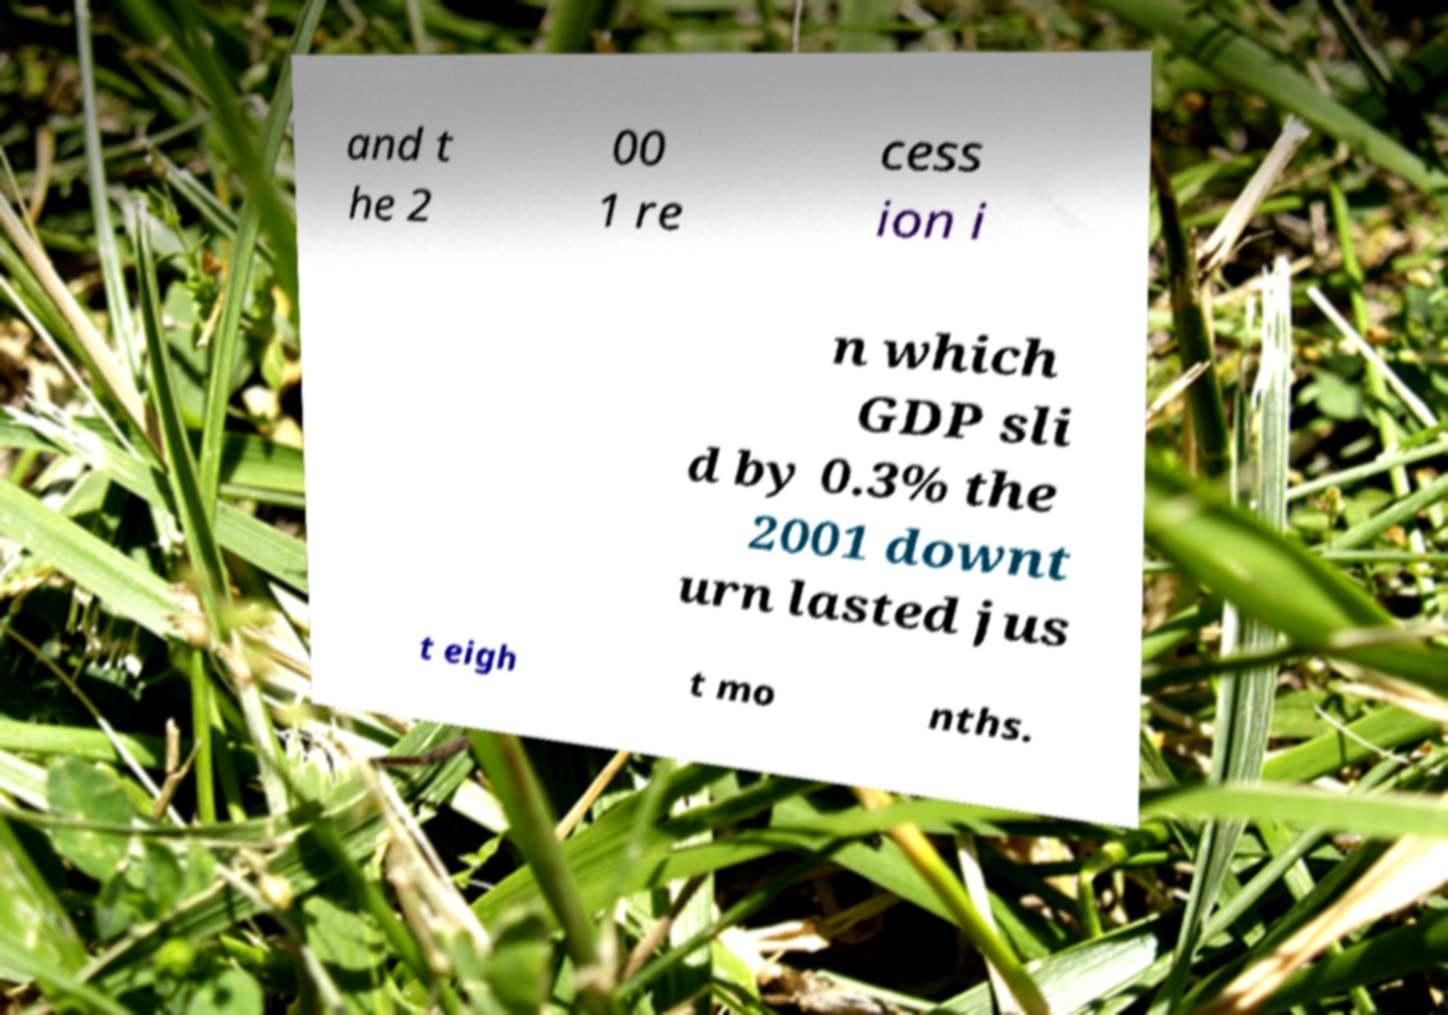What messages or text are displayed in this image? I need them in a readable, typed format. and t he 2 00 1 re cess ion i n which GDP sli d by 0.3% the 2001 downt urn lasted jus t eigh t mo nths. 